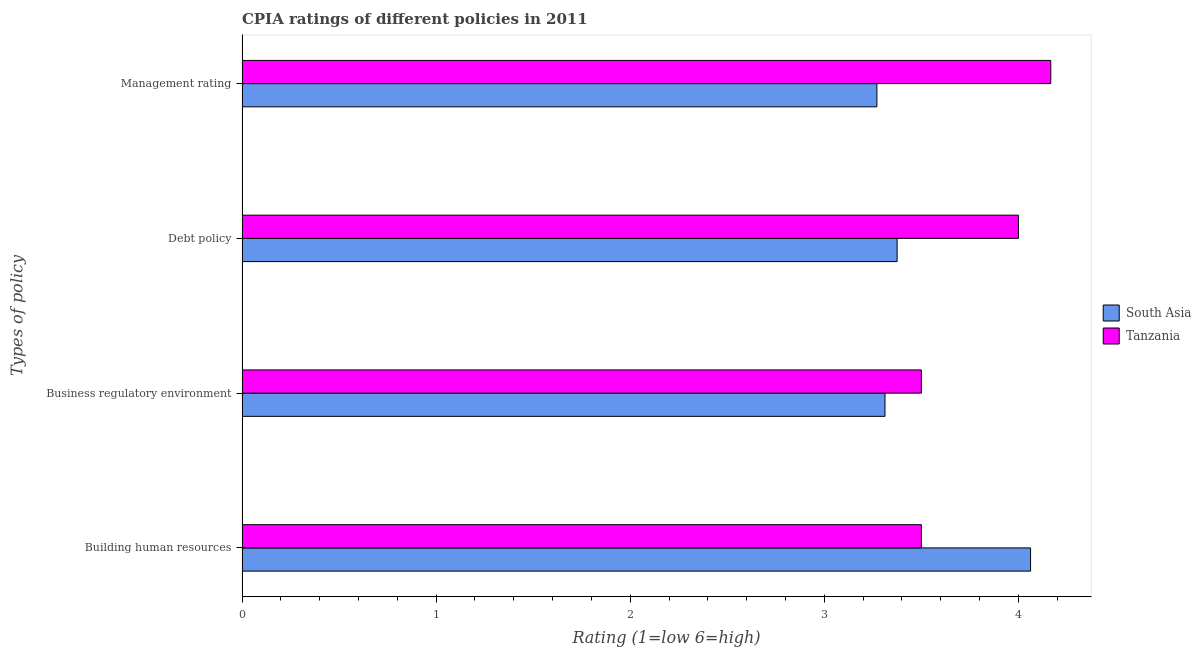How many different coloured bars are there?
Your response must be concise. 2. How many groups of bars are there?
Provide a short and direct response. 4. Are the number of bars on each tick of the Y-axis equal?
Provide a succinct answer. Yes. How many bars are there on the 1st tick from the top?
Ensure brevity in your answer.  2. How many bars are there on the 4th tick from the bottom?
Provide a succinct answer. 2. What is the label of the 1st group of bars from the top?
Offer a terse response. Management rating. What is the cpia rating of management in Tanzania?
Ensure brevity in your answer.  4.17. Across all countries, what is the maximum cpia rating of business regulatory environment?
Offer a very short reply. 3.5. Across all countries, what is the minimum cpia rating of debt policy?
Provide a succinct answer. 3.38. In which country was the cpia rating of debt policy maximum?
Your response must be concise. Tanzania. In which country was the cpia rating of management minimum?
Your answer should be very brief. South Asia. What is the total cpia rating of business regulatory environment in the graph?
Provide a succinct answer. 6.81. What is the difference between the cpia rating of business regulatory environment in Tanzania and that in South Asia?
Make the answer very short. 0.19. What is the difference between the cpia rating of management in South Asia and the cpia rating of building human resources in Tanzania?
Provide a short and direct response. -0.23. What is the average cpia rating of building human resources per country?
Offer a very short reply. 3.78. What is the difference between the cpia rating of business regulatory environment and cpia rating of building human resources in South Asia?
Provide a succinct answer. -0.75. In how many countries, is the cpia rating of management greater than 0.2 ?
Provide a short and direct response. 2. What is the ratio of the cpia rating of management in Tanzania to that in South Asia?
Your answer should be very brief. 1.27. Is the difference between the cpia rating of building human resources in Tanzania and South Asia greater than the difference between the cpia rating of debt policy in Tanzania and South Asia?
Your response must be concise. No. What is the difference between the highest and the second highest cpia rating of building human resources?
Your response must be concise. 0.56. What is the difference between the highest and the lowest cpia rating of business regulatory environment?
Give a very brief answer. 0.19. Is the sum of the cpia rating of management in Tanzania and South Asia greater than the maximum cpia rating of business regulatory environment across all countries?
Offer a terse response. Yes. Is it the case that in every country, the sum of the cpia rating of debt policy and cpia rating of building human resources is greater than the sum of cpia rating of business regulatory environment and cpia rating of management?
Your response must be concise. Yes. What does the 1st bar from the bottom in Building human resources represents?
Keep it short and to the point. South Asia. Is it the case that in every country, the sum of the cpia rating of building human resources and cpia rating of business regulatory environment is greater than the cpia rating of debt policy?
Provide a succinct answer. Yes. How many bars are there?
Offer a very short reply. 8. Are all the bars in the graph horizontal?
Your response must be concise. Yes. How many countries are there in the graph?
Offer a very short reply. 2. Are the values on the major ticks of X-axis written in scientific E-notation?
Make the answer very short. No. Does the graph contain grids?
Provide a succinct answer. No. What is the title of the graph?
Ensure brevity in your answer.  CPIA ratings of different policies in 2011. What is the label or title of the X-axis?
Ensure brevity in your answer.  Rating (1=low 6=high). What is the label or title of the Y-axis?
Offer a very short reply. Types of policy. What is the Rating (1=low 6=high) in South Asia in Building human resources?
Offer a terse response. 4.06. What is the Rating (1=low 6=high) of South Asia in Business regulatory environment?
Your answer should be very brief. 3.31. What is the Rating (1=low 6=high) of Tanzania in Business regulatory environment?
Your answer should be compact. 3.5. What is the Rating (1=low 6=high) of South Asia in Debt policy?
Provide a succinct answer. 3.38. What is the Rating (1=low 6=high) in South Asia in Management rating?
Provide a short and direct response. 3.27. What is the Rating (1=low 6=high) of Tanzania in Management rating?
Give a very brief answer. 4.17. Across all Types of policy, what is the maximum Rating (1=low 6=high) in South Asia?
Make the answer very short. 4.06. Across all Types of policy, what is the maximum Rating (1=low 6=high) in Tanzania?
Offer a very short reply. 4.17. Across all Types of policy, what is the minimum Rating (1=low 6=high) in South Asia?
Keep it short and to the point. 3.27. What is the total Rating (1=low 6=high) in South Asia in the graph?
Your response must be concise. 14.02. What is the total Rating (1=low 6=high) in Tanzania in the graph?
Make the answer very short. 15.17. What is the difference between the Rating (1=low 6=high) in South Asia in Building human resources and that in Business regulatory environment?
Make the answer very short. 0.75. What is the difference between the Rating (1=low 6=high) in South Asia in Building human resources and that in Debt policy?
Make the answer very short. 0.69. What is the difference between the Rating (1=low 6=high) in Tanzania in Building human resources and that in Debt policy?
Keep it short and to the point. -0.5. What is the difference between the Rating (1=low 6=high) of South Asia in Building human resources and that in Management rating?
Provide a succinct answer. 0.79. What is the difference between the Rating (1=low 6=high) in South Asia in Business regulatory environment and that in Debt policy?
Provide a short and direct response. -0.06. What is the difference between the Rating (1=low 6=high) in Tanzania in Business regulatory environment and that in Debt policy?
Offer a terse response. -0.5. What is the difference between the Rating (1=low 6=high) in South Asia in Business regulatory environment and that in Management rating?
Offer a terse response. 0.04. What is the difference between the Rating (1=low 6=high) in South Asia in Debt policy and that in Management rating?
Provide a succinct answer. 0.1. What is the difference between the Rating (1=low 6=high) of Tanzania in Debt policy and that in Management rating?
Make the answer very short. -0.17. What is the difference between the Rating (1=low 6=high) in South Asia in Building human resources and the Rating (1=low 6=high) in Tanzania in Business regulatory environment?
Give a very brief answer. 0.56. What is the difference between the Rating (1=low 6=high) in South Asia in Building human resources and the Rating (1=low 6=high) in Tanzania in Debt policy?
Offer a very short reply. 0.06. What is the difference between the Rating (1=low 6=high) of South Asia in Building human resources and the Rating (1=low 6=high) of Tanzania in Management rating?
Offer a terse response. -0.1. What is the difference between the Rating (1=low 6=high) in South Asia in Business regulatory environment and the Rating (1=low 6=high) in Tanzania in Debt policy?
Keep it short and to the point. -0.69. What is the difference between the Rating (1=low 6=high) of South Asia in Business regulatory environment and the Rating (1=low 6=high) of Tanzania in Management rating?
Ensure brevity in your answer.  -0.85. What is the difference between the Rating (1=low 6=high) of South Asia in Debt policy and the Rating (1=low 6=high) of Tanzania in Management rating?
Give a very brief answer. -0.79. What is the average Rating (1=low 6=high) of South Asia per Types of policy?
Offer a terse response. 3.51. What is the average Rating (1=low 6=high) of Tanzania per Types of policy?
Keep it short and to the point. 3.79. What is the difference between the Rating (1=low 6=high) of South Asia and Rating (1=low 6=high) of Tanzania in Building human resources?
Provide a succinct answer. 0.56. What is the difference between the Rating (1=low 6=high) in South Asia and Rating (1=low 6=high) in Tanzania in Business regulatory environment?
Your response must be concise. -0.19. What is the difference between the Rating (1=low 6=high) of South Asia and Rating (1=low 6=high) of Tanzania in Debt policy?
Your response must be concise. -0.62. What is the difference between the Rating (1=low 6=high) of South Asia and Rating (1=low 6=high) of Tanzania in Management rating?
Give a very brief answer. -0.9. What is the ratio of the Rating (1=low 6=high) in South Asia in Building human resources to that in Business regulatory environment?
Your answer should be very brief. 1.23. What is the ratio of the Rating (1=low 6=high) of South Asia in Building human resources to that in Debt policy?
Keep it short and to the point. 1.2. What is the ratio of the Rating (1=low 6=high) in Tanzania in Building human resources to that in Debt policy?
Ensure brevity in your answer.  0.88. What is the ratio of the Rating (1=low 6=high) in South Asia in Building human resources to that in Management rating?
Your answer should be very brief. 1.24. What is the ratio of the Rating (1=low 6=high) of Tanzania in Building human resources to that in Management rating?
Make the answer very short. 0.84. What is the ratio of the Rating (1=low 6=high) in South Asia in Business regulatory environment to that in Debt policy?
Ensure brevity in your answer.  0.98. What is the ratio of the Rating (1=low 6=high) of South Asia in Business regulatory environment to that in Management rating?
Offer a very short reply. 1.01. What is the ratio of the Rating (1=low 6=high) of Tanzania in Business regulatory environment to that in Management rating?
Your response must be concise. 0.84. What is the ratio of the Rating (1=low 6=high) of South Asia in Debt policy to that in Management rating?
Keep it short and to the point. 1.03. What is the ratio of the Rating (1=low 6=high) in Tanzania in Debt policy to that in Management rating?
Ensure brevity in your answer.  0.96. What is the difference between the highest and the second highest Rating (1=low 6=high) of South Asia?
Your response must be concise. 0.69. What is the difference between the highest and the lowest Rating (1=low 6=high) of South Asia?
Offer a terse response. 0.79. 